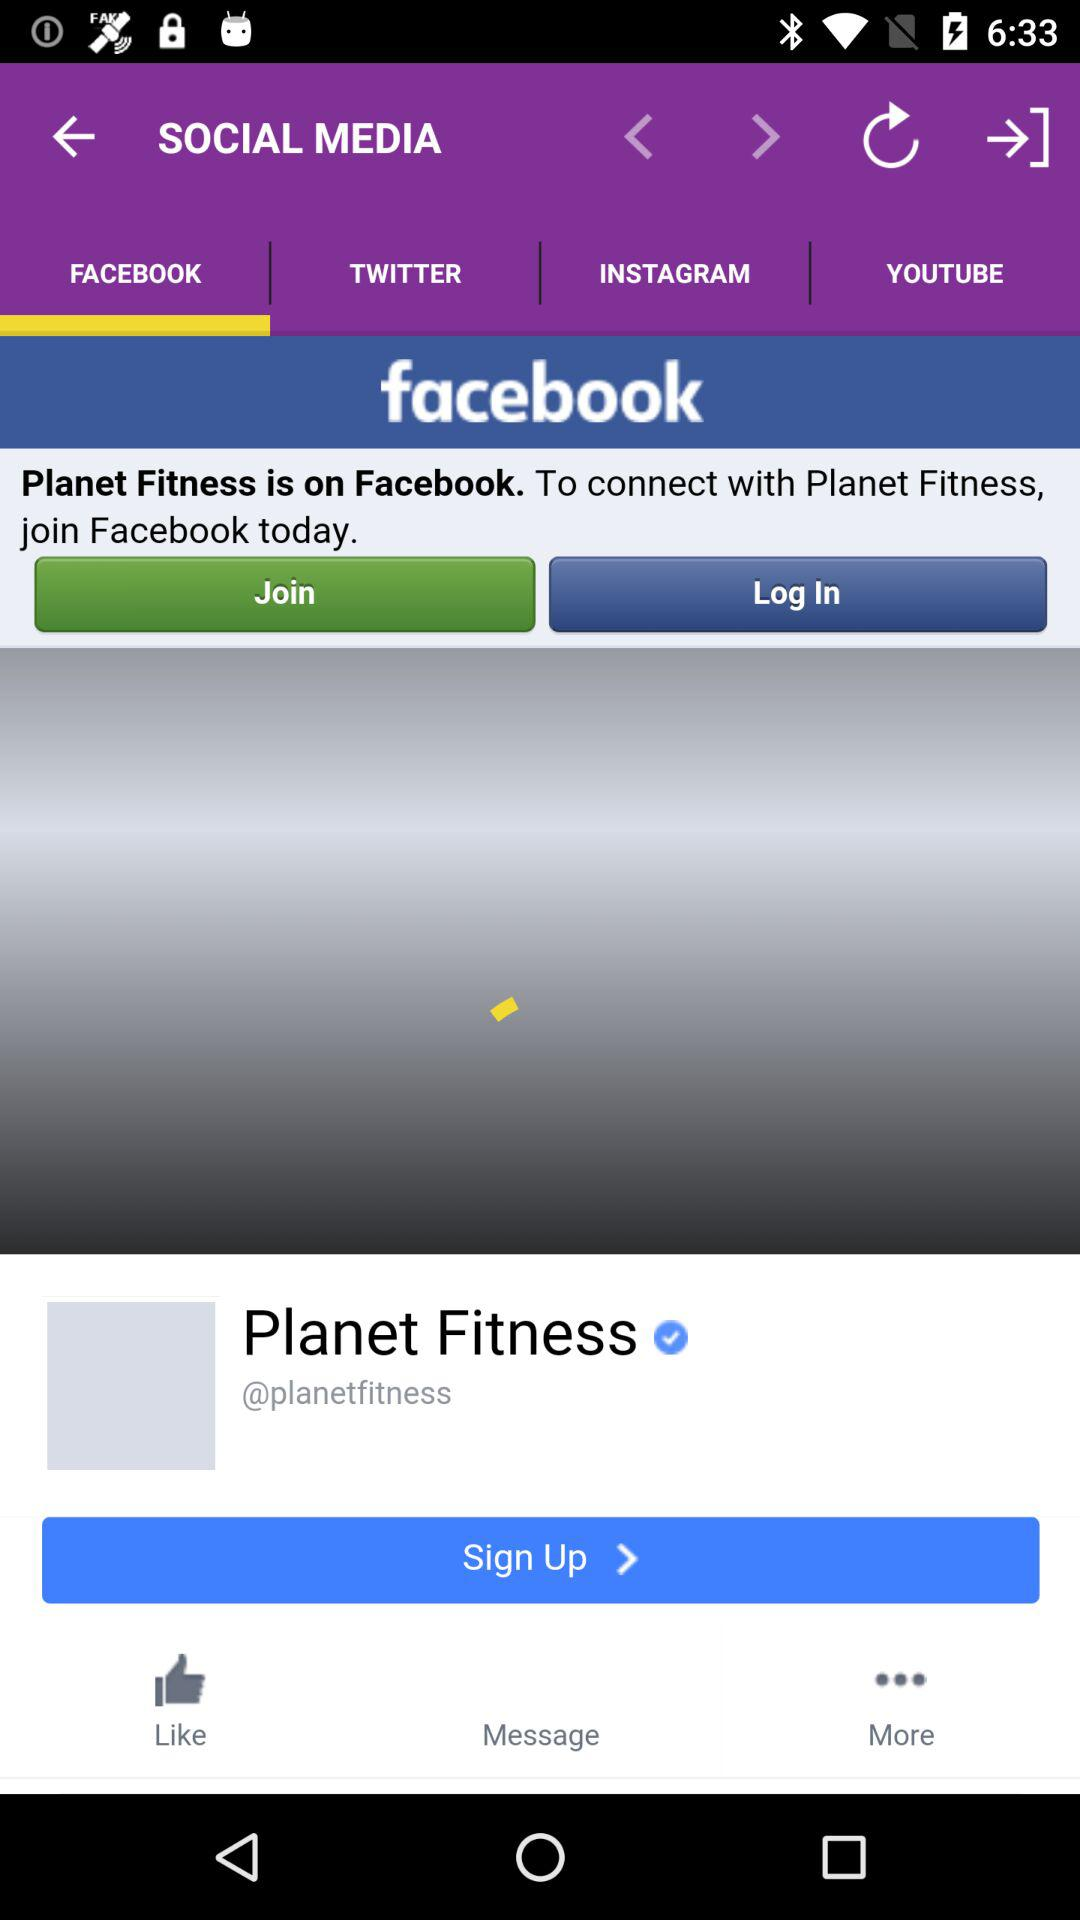How many followers does Planet Fitness have?
When the provided information is insufficient, respond with <no answer>. <no answer> 